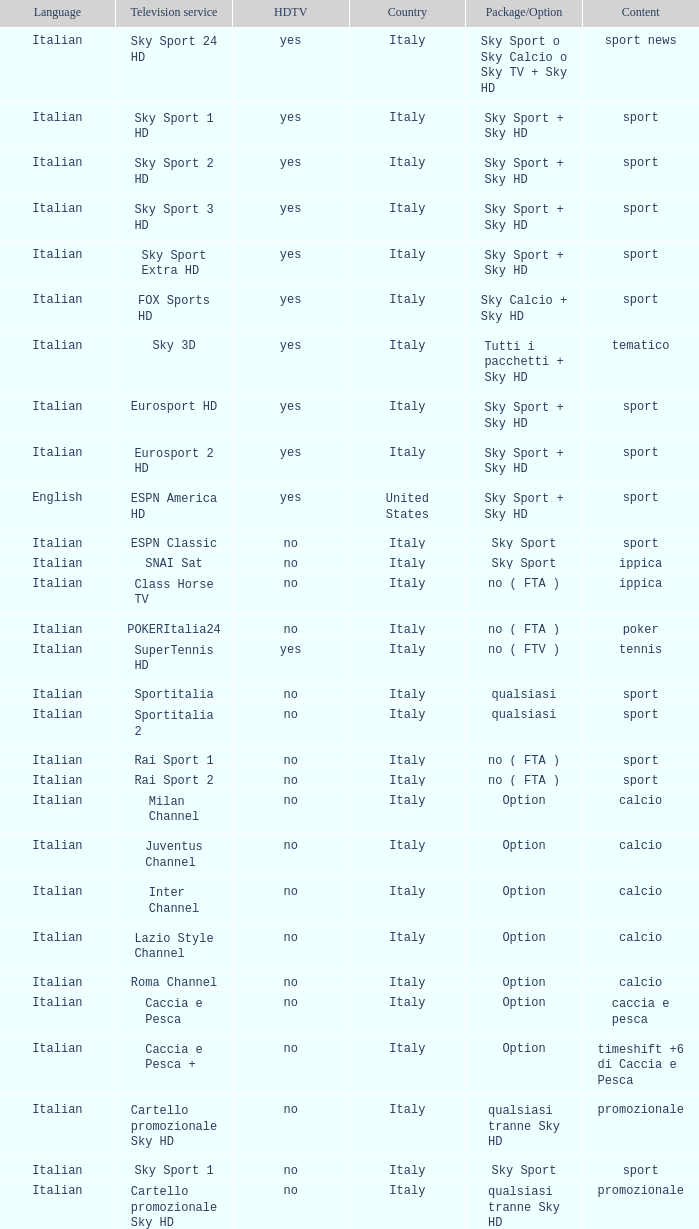What is Package/Option, when Content is Poker? No ( fta ). 